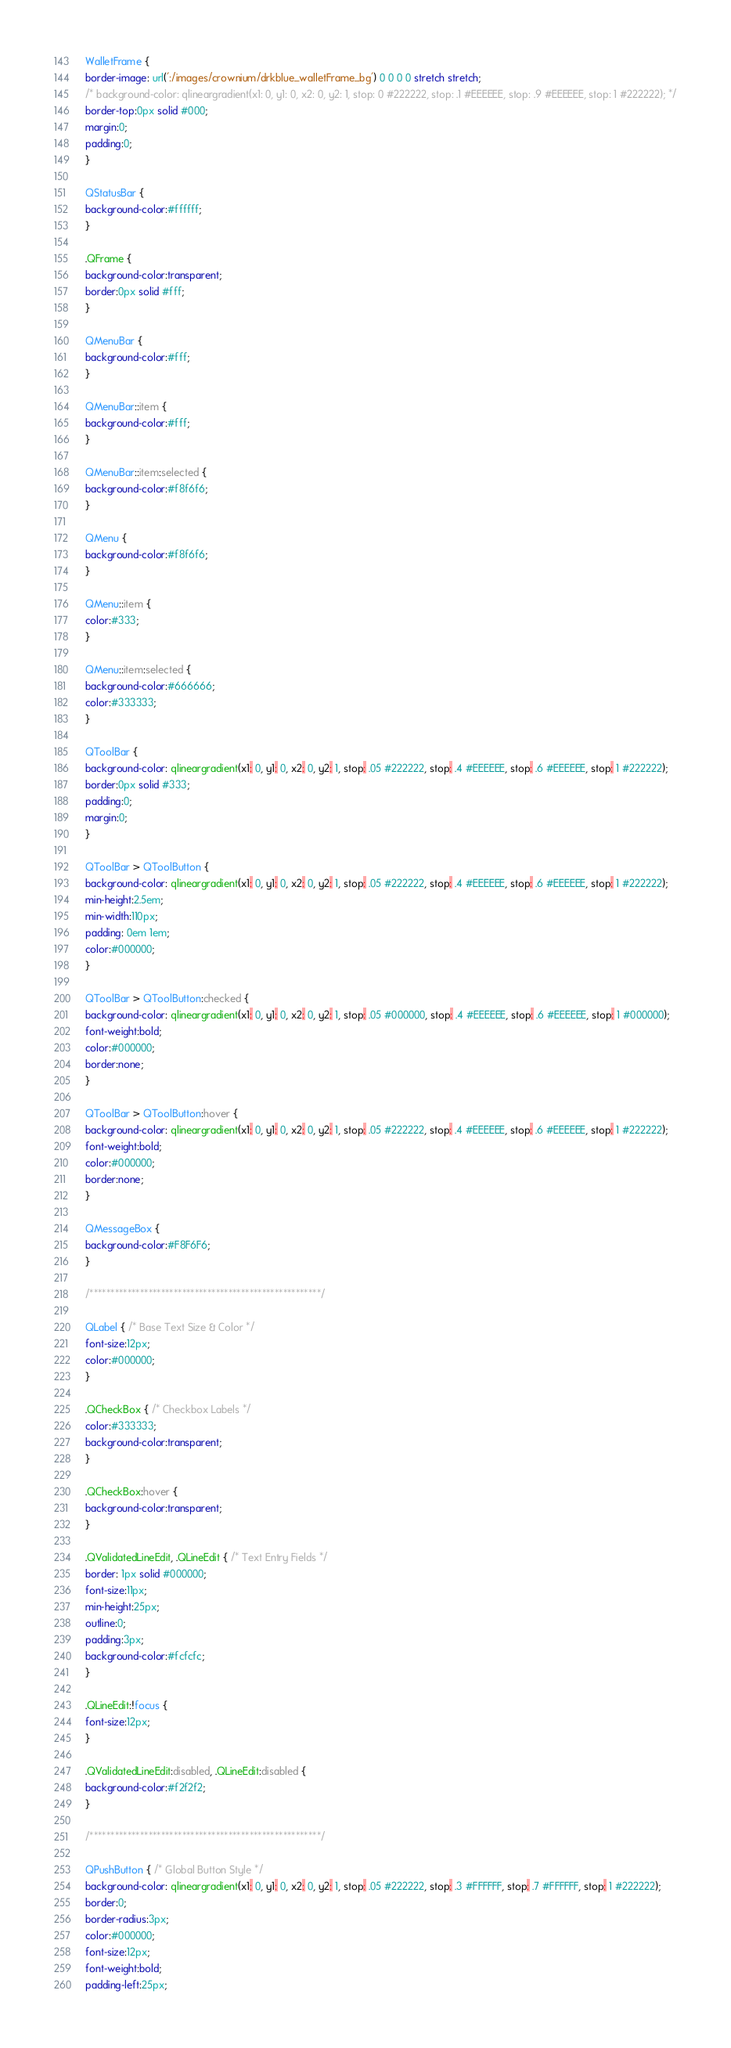<code> <loc_0><loc_0><loc_500><loc_500><_CSS_>WalletFrame {
border-image: url(':/images/crownium/drkblue_walletFrame_bg') 0 0 0 0 stretch stretch;
/* background-color: qlineargradient(x1: 0, y1: 0, x2: 0, y2: 1, stop: 0 #222222, stop: .1 #EEEEEE, stop: .9 #EEEEEE, stop: 1 #222222); */
border-top:0px solid #000;
margin:0;
padding:0;
}

QStatusBar {
background-color:#ffffff;
}

.QFrame {
background-color:transparent;
border:0px solid #fff;
}

QMenuBar {
background-color:#fff;
}

QMenuBar::item {
background-color:#fff;
}

QMenuBar::item:selected {
background-color:#f8f6f6;
}

QMenu {
background-color:#f8f6f6;
}

QMenu::item {
color:#333;
}

QMenu::item:selected {
background-color:#666666;
color:#333333;
}

QToolBar {
background-color: qlineargradient(x1: 0, y1: 0, x2: 0, y2: 1, stop: .05 #222222, stop: .4 #EEEEEE, stop: .6 #EEEEEE, stop: 1 #222222);
border:0px solid #333;
padding:0;
margin:0;
}

QToolBar > QToolButton {
background-color: qlineargradient(x1: 0, y1: 0, x2: 0, y2: 1, stop: .05 #222222, stop: .4 #EEEEEE, stop: .6 #EEEEEE, stop: 1 #222222);
min-height:2.5em;
min-width:110px;
padding: 0em 1em;
color:#000000;
}

QToolBar > QToolButton:checked {
background-color: qlineargradient(x1: 0, y1: 0, x2: 0, y2: 1, stop: .05 #000000, stop: .4 #EEEEEE, stop: .6 #EEEEEE, stop: 1 #000000);
font-weight:bold;
color:#000000;
border:none;
}

QToolBar > QToolButton:hover {
background-color: qlineargradient(x1: 0, y1: 0, x2: 0, y2: 1, stop: .05 #222222, stop: .4 #EEEEEE, stop: .6 #EEEEEE, stop: 1 #222222);
font-weight:bold;
color:#000000;
border:none;
}

QMessageBox {
background-color:#F8F6F6;
}

/*******************************************************/

QLabel { /* Base Text Size & Color */
font-size:12px;
color:#000000;
}

.QCheckBox { /* Checkbox Labels */
color:#333333;
background-color:transparent;
}

.QCheckBox:hover {
background-color:transparent;
}

.QValidatedLineEdit, .QLineEdit { /* Text Entry Fields */
border: 1px solid #000000;
font-size:11px;
min-height:25px;
outline:0;
padding:3px;
background-color:#fcfcfc;
}

.QLineEdit:!focus {
font-size:12px;
}

.QValidatedLineEdit:disabled, .QLineEdit:disabled {
background-color:#f2f2f2;
}

/*******************************************************/

QPushButton { /* Global Button Style */
background-color: qlineargradient(x1: 0, y1: 0, x2: 0, y2: 1, stop: .05 #222222, stop: .3 #FFFFFF, stop: .7 #FFFFFF, stop: 1 #222222);
border:0;
border-radius:3px;
color:#000000;
font-size:12px;
font-weight:bold;
padding-left:25px;</code> 